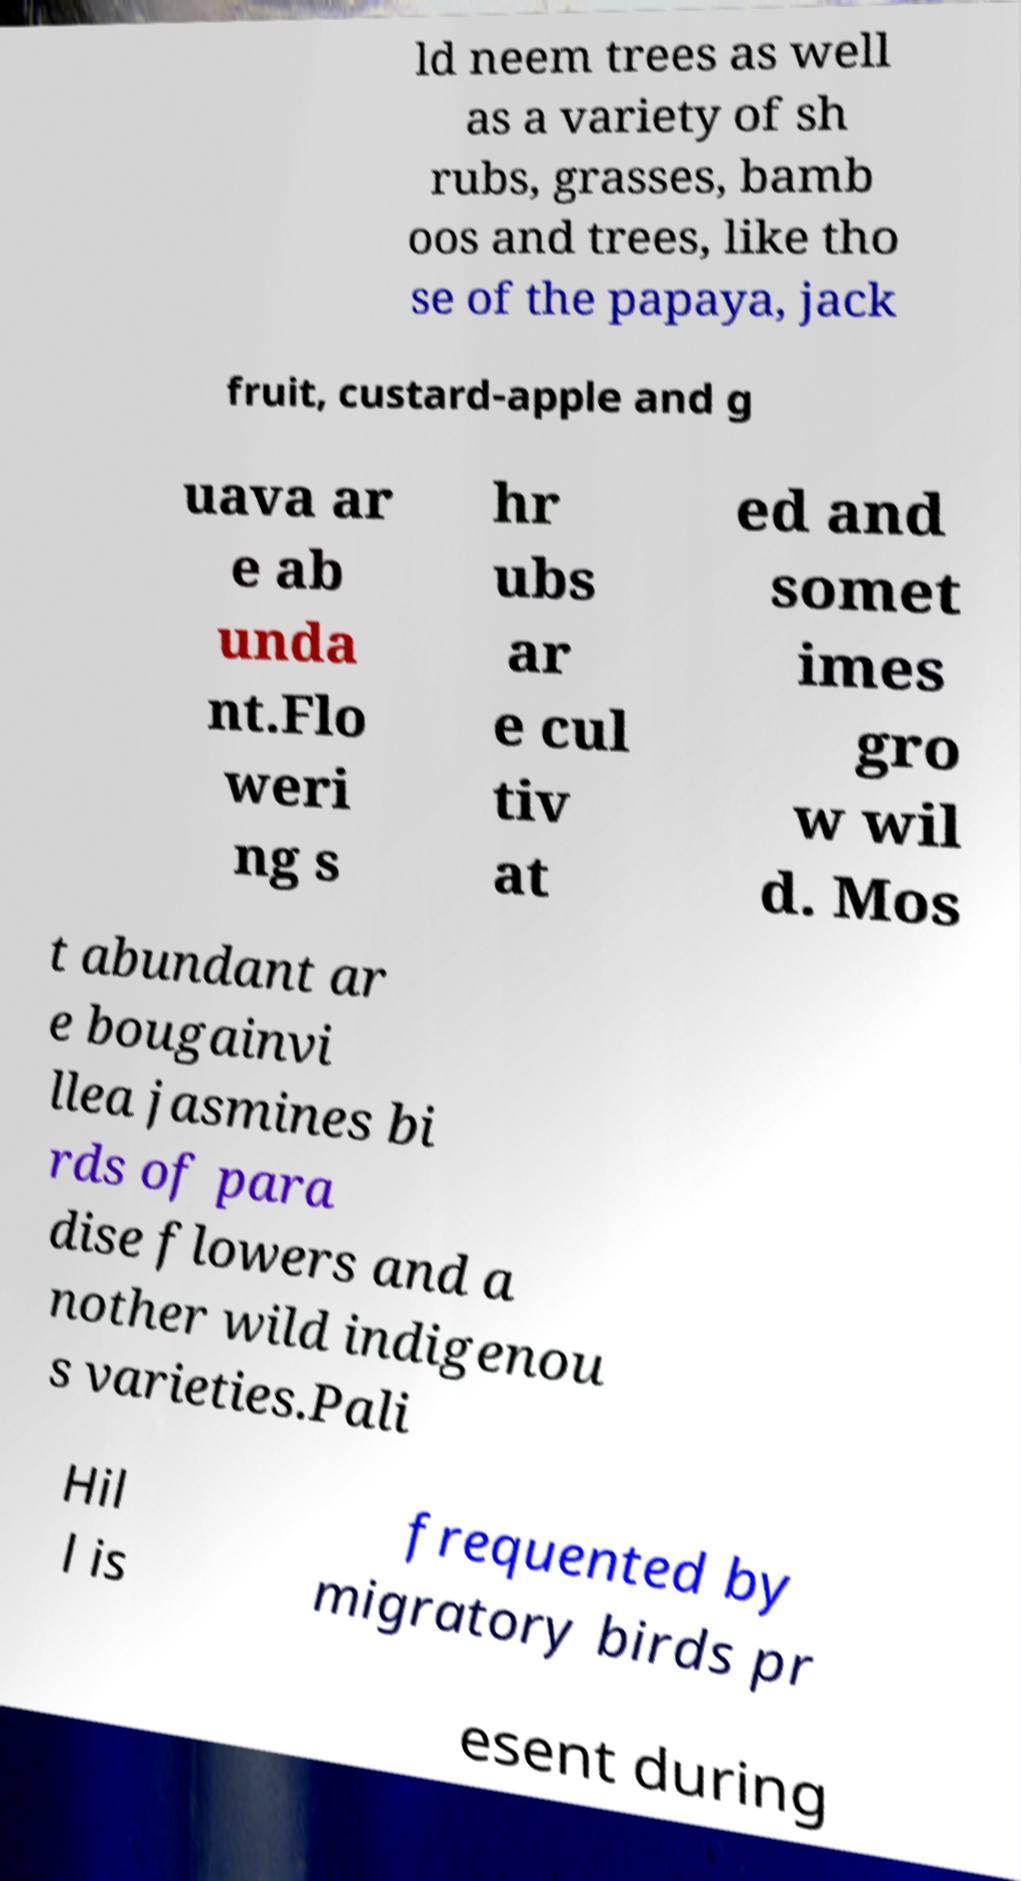What messages or text are displayed in this image? I need them in a readable, typed format. ld neem trees as well as a variety of sh rubs, grasses, bamb oos and trees, like tho se of the papaya, jack fruit, custard-apple and g uava ar e ab unda nt.Flo weri ng s hr ubs ar e cul tiv at ed and somet imes gro w wil d. Mos t abundant ar e bougainvi llea jasmines bi rds of para dise flowers and a nother wild indigenou s varieties.Pali Hil l is frequented by migratory birds pr esent during 